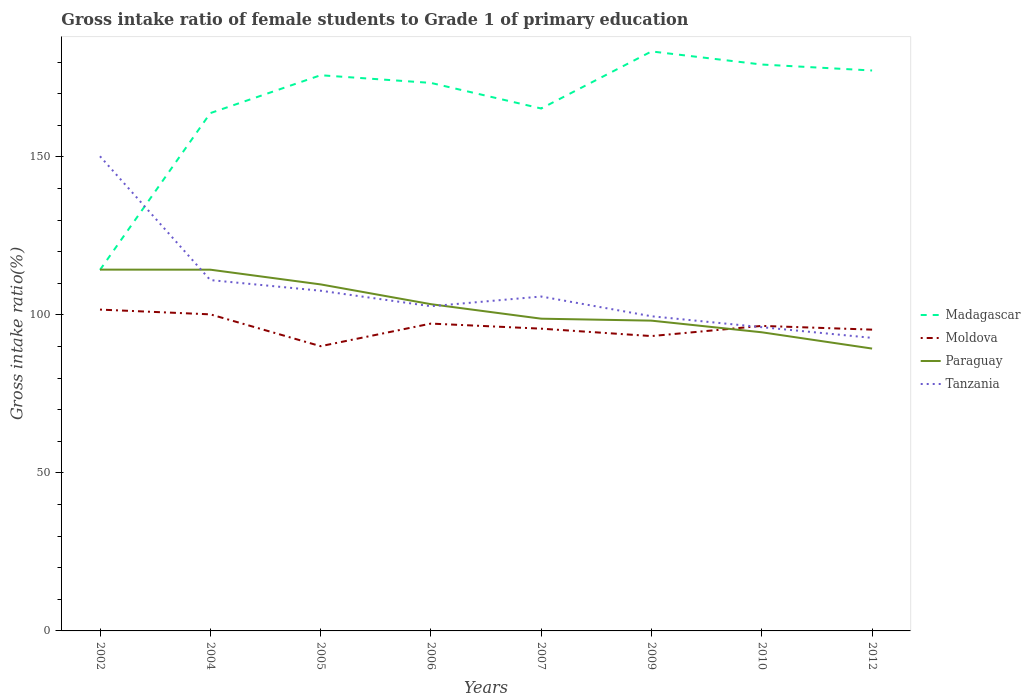How many different coloured lines are there?
Provide a succinct answer. 4. Does the line corresponding to Paraguay intersect with the line corresponding to Tanzania?
Ensure brevity in your answer.  Yes. Across all years, what is the maximum gross intake ratio in Paraguay?
Your response must be concise. 89.35. What is the total gross intake ratio in Paraguay in the graph?
Provide a short and direct response. 4.66. What is the difference between the highest and the second highest gross intake ratio in Tanzania?
Your answer should be very brief. 57.47. Is the gross intake ratio in Moldova strictly greater than the gross intake ratio in Tanzania over the years?
Your answer should be compact. No. How many lines are there?
Make the answer very short. 4. How many years are there in the graph?
Provide a short and direct response. 8. What is the difference between two consecutive major ticks on the Y-axis?
Your answer should be very brief. 50. Are the values on the major ticks of Y-axis written in scientific E-notation?
Offer a very short reply. No. Does the graph contain grids?
Give a very brief answer. No. Where does the legend appear in the graph?
Offer a terse response. Center right. What is the title of the graph?
Give a very brief answer. Gross intake ratio of female students to Grade 1 of primary education. What is the label or title of the Y-axis?
Make the answer very short. Gross intake ratio(%). What is the Gross intake ratio(%) of Madagascar in 2002?
Offer a terse response. 114.24. What is the Gross intake ratio(%) in Moldova in 2002?
Provide a short and direct response. 101.68. What is the Gross intake ratio(%) of Paraguay in 2002?
Your answer should be very brief. 114.33. What is the Gross intake ratio(%) in Tanzania in 2002?
Make the answer very short. 150.2. What is the Gross intake ratio(%) in Madagascar in 2004?
Provide a short and direct response. 163.85. What is the Gross intake ratio(%) in Moldova in 2004?
Make the answer very short. 100.18. What is the Gross intake ratio(%) of Paraguay in 2004?
Make the answer very short. 114.31. What is the Gross intake ratio(%) of Tanzania in 2004?
Your response must be concise. 111.02. What is the Gross intake ratio(%) of Madagascar in 2005?
Keep it short and to the point. 175.84. What is the Gross intake ratio(%) in Moldova in 2005?
Your response must be concise. 90.1. What is the Gross intake ratio(%) of Paraguay in 2005?
Keep it short and to the point. 109.65. What is the Gross intake ratio(%) in Tanzania in 2005?
Your response must be concise. 107.65. What is the Gross intake ratio(%) of Madagascar in 2006?
Provide a short and direct response. 173.41. What is the Gross intake ratio(%) in Moldova in 2006?
Your answer should be compact. 97.25. What is the Gross intake ratio(%) in Paraguay in 2006?
Provide a short and direct response. 103.4. What is the Gross intake ratio(%) in Tanzania in 2006?
Ensure brevity in your answer.  102.75. What is the Gross intake ratio(%) in Madagascar in 2007?
Offer a terse response. 165.32. What is the Gross intake ratio(%) in Moldova in 2007?
Ensure brevity in your answer.  95.64. What is the Gross intake ratio(%) in Paraguay in 2007?
Keep it short and to the point. 98.8. What is the Gross intake ratio(%) in Tanzania in 2007?
Ensure brevity in your answer.  105.82. What is the Gross intake ratio(%) in Madagascar in 2009?
Keep it short and to the point. 183.37. What is the Gross intake ratio(%) in Moldova in 2009?
Provide a succinct answer. 93.3. What is the Gross intake ratio(%) of Paraguay in 2009?
Provide a succinct answer. 98.18. What is the Gross intake ratio(%) of Tanzania in 2009?
Offer a very short reply. 99.57. What is the Gross intake ratio(%) of Madagascar in 2010?
Keep it short and to the point. 179.23. What is the Gross intake ratio(%) in Moldova in 2010?
Provide a short and direct response. 96.52. What is the Gross intake ratio(%) in Paraguay in 2010?
Give a very brief answer. 94.5. What is the Gross intake ratio(%) in Tanzania in 2010?
Make the answer very short. 96.12. What is the Gross intake ratio(%) in Madagascar in 2012?
Offer a very short reply. 177.34. What is the Gross intake ratio(%) of Moldova in 2012?
Provide a short and direct response. 95.34. What is the Gross intake ratio(%) of Paraguay in 2012?
Ensure brevity in your answer.  89.35. What is the Gross intake ratio(%) of Tanzania in 2012?
Provide a succinct answer. 92.73. Across all years, what is the maximum Gross intake ratio(%) in Madagascar?
Ensure brevity in your answer.  183.37. Across all years, what is the maximum Gross intake ratio(%) of Moldova?
Offer a very short reply. 101.68. Across all years, what is the maximum Gross intake ratio(%) in Paraguay?
Offer a terse response. 114.33. Across all years, what is the maximum Gross intake ratio(%) in Tanzania?
Offer a very short reply. 150.2. Across all years, what is the minimum Gross intake ratio(%) of Madagascar?
Ensure brevity in your answer.  114.24. Across all years, what is the minimum Gross intake ratio(%) of Moldova?
Offer a very short reply. 90.1. Across all years, what is the minimum Gross intake ratio(%) of Paraguay?
Give a very brief answer. 89.35. Across all years, what is the minimum Gross intake ratio(%) in Tanzania?
Make the answer very short. 92.73. What is the total Gross intake ratio(%) of Madagascar in the graph?
Provide a short and direct response. 1332.61. What is the total Gross intake ratio(%) in Moldova in the graph?
Ensure brevity in your answer.  770.02. What is the total Gross intake ratio(%) of Paraguay in the graph?
Offer a very short reply. 822.53. What is the total Gross intake ratio(%) of Tanzania in the graph?
Give a very brief answer. 865.86. What is the difference between the Gross intake ratio(%) in Madagascar in 2002 and that in 2004?
Keep it short and to the point. -49.61. What is the difference between the Gross intake ratio(%) of Moldova in 2002 and that in 2004?
Your answer should be very brief. 1.5. What is the difference between the Gross intake ratio(%) in Paraguay in 2002 and that in 2004?
Ensure brevity in your answer.  0.02. What is the difference between the Gross intake ratio(%) of Tanzania in 2002 and that in 2004?
Offer a terse response. 39.18. What is the difference between the Gross intake ratio(%) of Madagascar in 2002 and that in 2005?
Offer a terse response. -61.6. What is the difference between the Gross intake ratio(%) in Moldova in 2002 and that in 2005?
Your answer should be compact. 11.58. What is the difference between the Gross intake ratio(%) in Paraguay in 2002 and that in 2005?
Provide a short and direct response. 4.67. What is the difference between the Gross intake ratio(%) in Tanzania in 2002 and that in 2005?
Keep it short and to the point. 42.55. What is the difference between the Gross intake ratio(%) in Madagascar in 2002 and that in 2006?
Ensure brevity in your answer.  -59.17. What is the difference between the Gross intake ratio(%) in Moldova in 2002 and that in 2006?
Provide a short and direct response. 4.43. What is the difference between the Gross intake ratio(%) in Paraguay in 2002 and that in 2006?
Provide a succinct answer. 10.93. What is the difference between the Gross intake ratio(%) in Tanzania in 2002 and that in 2006?
Your response must be concise. 47.45. What is the difference between the Gross intake ratio(%) in Madagascar in 2002 and that in 2007?
Ensure brevity in your answer.  -51.07. What is the difference between the Gross intake ratio(%) of Moldova in 2002 and that in 2007?
Provide a short and direct response. 6.04. What is the difference between the Gross intake ratio(%) of Paraguay in 2002 and that in 2007?
Provide a succinct answer. 15.52. What is the difference between the Gross intake ratio(%) in Tanzania in 2002 and that in 2007?
Provide a short and direct response. 44.38. What is the difference between the Gross intake ratio(%) in Madagascar in 2002 and that in 2009?
Provide a succinct answer. -69.13. What is the difference between the Gross intake ratio(%) of Moldova in 2002 and that in 2009?
Your answer should be compact. 8.38. What is the difference between the Gross intake ratio(%) in Paraguay in 2002 and that in 2009?
Ensure brevity in your answer.  16.14. What is the difference between the Gross intake ratio(%) of Tanzania in 2002 and that in 2009?
Ensure brevity in your answer.  50.63. What is the difference between the Gross intake ratio(%) in Madagascar in 2002 and that in 2010?
Keep it short and to the point. -64.99. What is the difference between the Gross intake ratio(%) in Moldova in 2002 and that in 2010?
Provide a succinct answer. 5.16. What is the difference between the Gross intake ratio(%) in Paraguay in 2002 and that in 2010?
Your answer should be compact. 19.83. What is the difference between the Gross intake ratio(%) in Tanzania in 2002 and that in 2010?
Keep it short and to the point. 54.09. What is the difference between the Gross intake ratio(%) in Madagascar in 2002 and that in 2012?
Your answer should be very brief. -63.1. What is the difference between the Gross intake ratio(%) of Moldova in 2002 and that in 2012?
Offer a very short reply. 6.34. What is the difference between the Gross intake ratio(%) of Paraguay in 2002 and that in 2012?
Ensure brevity in your answer.  24.98. What is the difference between the Gross intake ratio(%) of Tanzania in 2002 and that in 2012?
Provide a succinct answer. 57.47. What is the difference between the Gross intake ratio(%) in Madagascar in 2004 and that in 2005?
Offer a very short reply. -11.99. What is the difference between the Gross intake ratio(%) in Moldova in 2004 and that in 2005?
Offer a terse response. 10.08. What is the difference between the Gross intake ratio(%) of Paraguay in 2004 and that in 2005?
Your answer should be compact. 4.66. What is the difference between the Gross intake ratio(%) of Tanzania in 2004 and that in 2005?
Keep it short and to the point. 3.37. What is the difference between the Gross intake ratio(%) in Madagascar in 2004 and that in 2006?
Your response must be concise. -9.56. What is the difference between the Gross intake ratio(%) of Moldova in 2004 and that in 2006?
Your answer should be very brief. 2.92. What is the difference between the Gross intake ratio(%) of Paraguay in 2004 and that in 2006?
Your response must be concise. 10.91. What is the difference between the Gross intake ratio(%) of Tanzania in 2004 and that in 2006?
Offer a terse response. 8.27. What is the difference between the Gross intake ratio(%) of Madagascar in 2004 and that in 2007?
Your answer should be compact. -1.46. What is the difference between the Gross intake ratio(%) in Moldova in 2004 and that in 2007?
Give a very brief answer. 4.53. What is the difference between the Gross intake ratio(%) of Paraguay in 2004 and that in 2007?
Give a very brief answer. 15.51. What is the difference between the Gross intake ratio(%) in Tanzania in 2004 and that in 2007?
Your answer should be compact. 5.2. What is the difference between the Gross intake ratio(%) in Madagascar in 2004 and that in 2009?
Make the answer very short. -19.52. What is the difference between the Gross intake ratio(%) of Moldova in 2004 and that in 2009?
Provide a succinct answer. 6.87. What is the difference between the Gross intake ratio(%) in Paraguay in 2004 and that in 2009?
Keep it short and to the point. 16.13. What is the difference between the Gross intake ratio(%) in Tanzania in 2004 and that in 2009?
Offer a very short reply. 11.45. What is the difference between the Gross intake ratio(%) of Madagascar in 2004 and that in 2010?
Your answer should be very brief. -15.38. What is the difference between the Gross intake ratio(%) in Moldova in 2004 and that in 2010?
Your response must be concise. 3.65. What is the difference between the Gross intake ratio(%) in Paraguay in 2004 and that in 2010?
Keep it short and to the point. 19.81. What is the difference between the Gross intake ratio(%) of Tanzania in 2004 and that in 2010?
Your answer should be very brief. 14.9. What is the difference between the Gross intake ratio(%) in Madagascar in 2004 and that in 2012?
Offer a terse response. -13.49. What is the difference between the Gross intake ratio(%) of Moldova in 2004 and that in 2012?
Provide a short and direct response. 4.84. What is the difference between the Gross intake ratio(%) of Paraguay in 2004 and that in 2012?
Provide a succinct answer. 24.96. What is the difference between the Gross intake ratio(%) of Tanzania in 2004 and that in 2012?
Your response must be concise. 18.29. What is the difference between the Gross intake ratio(%) in Madagascar in 2005 and that in 2006?
Make the answer very short. 2.43. What is the difference between the Gross intake ratio(%) in Moldova in 2005 and that in 2006?
Your answer should be very brief. -7.15. What is the difference between the Gross intake ratio(%) in Paraguay in 2005 and that in 2006?
Ensure brevity in your answer.  6.26. What is the difference between the Gross intake ratio(%) in Tanzania in 2005 and that in 2006?
Provide a succinct answer. 4.91. What is the difference between the Gross intake ratio(%) of Madagascar in 2005 and that in 2007?
Provide a succinct answer. 10.53. What is the difference between the Gross intake ratio(%) of Moldova in 2005 and that in 2007?
Your answer should be compact. -5.54. What is the difference between the Gross intake ratio(%) of Paraguay in 2005 and that in 2007?
Provide a succinct answer. 10.85. What is the difference between the Gross intake ratio(%) of Tanzania in 2005 and that in 2007?
Provide a short and direct response. 1.83. What is the difference between the Gross intake ratio(%) in Madagascar in 2005 and that in 2009?
Ensure brevity in your answer.  -7.53. What is the difference between the Gross intake ratio(%) of Moldova in 2005 and that in 2009?
Provide a short and direct response. -3.2. What is the difference between the Gross intake ratio(%) of Paraguay in 2005 and that in 2009?
Keep it short and to the point. 11.47. What is the difference between the Gross intake ratio(%) in Tanzania in 2005 and that in 2009?
Your answer should be compact. 8.08. What is the difference between the Gross intake ratio(%) in Madagascar in 2005 and that in 2010?
Your answer should be compact. -3.39. What is the difference between the Gross intake ratio(%) of Moldova in 2005 and that in 2010?
Your answer should be very brief. -6.42. What is the difference between the Gross intake ratio(%) of Paraguay in 2005 and that in 2010?
Provide a succinct answer. 15.15. What is the difference between the Gross intake ratio(%) of Tanzania in 2005 and that in 2010?
Offer a very short reply. 11.54. What is the difference between the Gross intake ratio(%) of Madagascar in 2005 and that in 2012?
Your response must be concise. -1.5. What is the difference between the Gross intake ratio(%) of Moldova in 2005 and that in 2012?
Keep it short and to the point. -5.24. What is the difference between the Gross intake ratio(%) of Paraguay in 2005 and that in 2012?
Your answer should be very brief. 20.31. What is the difference between the Gross intake ratio(%) of Tanzania in 2005 and that in 2012?
Your answer should be compact. 14.92. What is the difference between the Gross intake ratio(%) of Madagascar in 2006 and that in 2007?
Ensure brevity in your answer.  8.1. What is the difference between the Gross intake ratio(%) in Moldova in 2006 and that in 2007?
Ensure brevity in your answer.  1.61. What is the difference between the Gross intake ratio(%) of Paraguay in 2006 and that in 2007?
Ensure brevity in your answer.  4.59. What is the difference between the Gross intake ratio(%) of Tanzania in 2006 and that in 2007?
Ensure brevity in your answer.  -3.07. What is the difference between the Gross intake ratio(%) of Madagascar in 2006 and that in 2009?
Offer a very short reply. -9.96. What is the difference between the Gross intake ratio(%) of Moldova in 2006 and that in 2009?
Offer a very short reply. 3.95. What is the difference between the Gross intake ratio(%) of Paraguay in 2006 and that in 2009?
Keep it short and to the point. 5.21. What is the difference between the Gross intake ratio(%) of Tanzania in 2006 and that in 2009?
Your response must be concise. 3.18. What is the difference between the Gross intake ratio(%) of Madagascar in 2006 and that in 2010?
Your response must be concise. -5.82. What is the difference between the Gross intake ratio(%) of Moldova in 2006 and that in 2010?
Offer a very short reply. 0.73. What is the difference between the Gross intake ratio(%) in Paraguay in 2006 and that in 2010?
Provide a succinct answer. 8.89. What is the difference between the Gross intake ratio(%) in Tanzania in 2006 and that in 2010?
Your answer should be compact. 6.63. What is the difference between the Gross intake ratio(%) in Madagascar in 2006 and that in 2012?
Keep it short and to the point. -3.93. What is the difference between the Gross intake ratio(%) of Moldova in 2006 and that in 2012?
Provide a short and direct response. 1.92. What is the difference between the Gross intake ratio(%) in Paraguay in 2006 and that in 2012?
Offer a terse response. 14.05. What is the difference between the Gross intake ratio(%) of Tanzania in 2006 and that in 2012?
Your answer should be very brief. 10.02. What is the difference between the Gross intake ratio(%) in Madagascar in 2007 and that in 2009?
Ensure brevity in your answer.  -18.06. What is the difference between the Gross intake ratio(%) of Moldova in 2007 and that in 2009?
Your answer should be compact. 2.34. What is the difference between the Gross intake ratio(%) of Paraguay in 2007 and that in 2009?
Make the answer very short. 0.62. What is the difference between the Gross intake ratio(%) in Tanzania in 2007 and that in 2009?
Provide a succinct answer. 6.25. What is the difference between the Gross intake ratio(%) in Madagascar in 2007 and that in 2010?
Your response must be concise. -13.91. What is the difference between the Gross intake ratio(%) in Moldova in 2007 and that in 2010?
Your answer should be compact. -0.88. What is the difference between the Gross intake ratio(%) in Paraguay in 2007 and that in 2010?
Provide a succinct answer. 4.3. What is the difference between the Gross intake ratio(%) in Tanzania in 2007 and that in 2010?
Ensure brevity in your answer.  9.7. What is the difference between the Gross intake ratio(%) of Madagascar in 2007 and that in 2012?
Your answer should be very brief. -12.02. What is the difference between the Gross intake ratio(%) in Moldova in 2007 and that in 2012?
Make the answer very short. 0.31. What is the difference between the Gross intake ratio(%) of Paraguay in 2007 and that in 2012?
Provide a succinct answer. 9.46. What is the difference between the Gross intake ratio(%) in Tanzania in 2007 and that in 2012?
Your answer should be compact. 13.09. What is the difference between the Gross intake ratio(%) of Madagascar in 2009 and that in 2010?
Make the answer very short. 4.14. What is the difference between the Gross intake ratio(%) of Moldova in 2009 and that in 2010?
Give a very brief answer. -3.22. What is the difference between the Gross intake ratio(%) in Paraguay in 2009 and that in 2010?
Give a very brief answer. 3.68. What is the difference between the Gross intake ratio(%) in Tanzania in 2009 and that in 2010?
Provide a succinct answer. 3.45. What is the difference between the Gross intake ratio(%) in Madagascar in 2009 and that in 2012?
Your answer should be compact. 6.03. What is the difference between the Gross intake ratio(%) of Moldova in 2009 and that in 2012?
Your response must be concise. -2.03. What is the difference between the Gross intake ratio(%) in Paraguay in 2009 and that in 2012?
Keep it short and to the point. 8.84. What is the difference between the Gross intake ratio(%) of Tanzania in 2009 and that in 2012?
Give a very brief answer. 6.84. What is the difference between the Gross intake ratio(%) in Madagascar in 2010 and that in 2012?
Your answer should be very brief. 1.89. What is the difference between the Gross intake ratio(%) of Moldova in 2010 and that in 2012?
Your response must be concise. 1.19. What is the difference between the Gross intake ratio(%) of Paraguay in 2010 and that in 2012?
Offer a very short reply. 5.15. What is the difference between the Gross intake ratio(%) in Tanzania in 2010 and that in 2012?
Your response must be concise. 3.38. What is the difference between the Gross intake ratio(%) in Madagascar in 2002 and the Gross intake ratio(%) in Moldova in 2004?
Ensure brevity in your answer.  14.07. What is the difference between the Gross intake ratio(%) in Madagascar in 2002 and the Gross intake ratio(%) in Paraguay in 2004?
Ensure brevity in your answer.  -0.07. What is the difference between the Gross intake ratio(%) of Madagascar in 2002 and the Gross intake ratio(%) of Tanzania in 2004?
Provide a short and direct response. 3.22. What is the difference between the Gross intake ratio(%) of Moldova in 2002 and the Gross intake ratio(%) of Paraguay in 2004?
Keep it short and to the point. -12.63. What is the difference between the Gross intake ratio(%) in Moldova in 2002 and the Gross intake ratio(%) in Tanzania in 2004?
Keep it short and to the point. -9.34. What is the difference between the Gross intake ratio(%) of Paraguay in 2002 and the Gross intake ratio(%) of Tanzania in 2004?
Give a very brief answer. 3.31. What is the difference between the Gross intake ratio(%) in Madagascar in 2002 and the Gross intake ratio(%) in Moldova in 2005?
Provide a short and direct response. 24.14. What is the difference between the Gross intake ratio(%) in Madagascar in 2002 and the Gross intake ratio(%) in Paraguay in 2005?
Provide a succinct answer. 4.59. What is the difference between the Gross intake ratio(%) of Madagascar in 2002 and the Gross intake ratio(%) of Tanzania in 2005?
Provide a short and direct response. 6.59. What is the difference between the Gross intake ratio(%) in Moldova in 2002 and the Gross intake ratio(%) in Paraguay in 2005?
Your answer should be very brief. -7.97. What is the difference between the Gross intake ratio(%) in Moldova in 2002 and the Gross intake ratio(%) in Tanzania in 2005?
Ensure brevity in your answer.  -5.97. What is the difference between the Gross intake ratio(%) of Paraguay in 2002 and the Gross intake ratio(%) of Tanzania in 2005?
Offer a terse response. 6.67. What is the difference between the Gross intake ratio(%) of Madagascar in 2002 and the Gross intake ratio(%) of Moldova in 2006?
Ensure brevity in your answer.  16.99. What is the difference between the Gross intake ratio(%) of Madagascar in 2002 and the Gross intake ratio(%) of Paraguay in 2006?
Your response must be concise. 10.85. What is the difference between the Gross intake ratio(%) in Madagascar in 2002 and the Gross intake ratio(%) in Tanzania in 2006?
Ensure brevity in your answer.  11.5. What is the difference between the Gross intake ratio(%) of Moldova in 2002 and the Gross intake ratio(%) of Paraguay in 2006?
Ensure brevity in your answer.  -1.72. What is the difference between the Gross intake ratio(%) of Moldova in 2002 and the Gross intake ratio(%) of Tanzania in 2006?
Make the answer very short. -1.07. What is the difference between the Gross intake ratio(%) of Paraguay in 2002 and the Gross intake ratio(%) of Tanzania in 2006?
Provide a short and direct response. 11.58. What is the difference between the Gross intake ratio(%) of Madagascar in 2002 and the Gross intake ratio(%) of Moldova in 2007?
Make the answer very short. 18.6. What is the difference between the Gross intake ratio(%) in Madagascar in 2002 and the Gross intake ratio(%) in Paraguay in 2007?
Provide a succinct answer. 15.44. What is the difference between the Gross intake ratio(%) of Madagascar in 2002 and the Gross intake ratio(%) of Tanzania in 2007?
Offer a terse response. 8.42. What is the difference between the Gross intake ratio(%) in Moldova in 2002 and the Gross intake ratio(%) in Paraguay in 2007?
Your answer should be compact. 2.88. What is the difference between the Gross intake ratio(%) in Moldova in 2002 and the Gross intake ratio(%) in Tanzania in 2007?
Provide a short and direct response. -4.14. What is the difference between the Gross intake ratio(%) in Paraguay in 2002 and the Gross intake ratio(%) in Tanzania in 2007?
Give a very brief answer. 8.51. What is the difference between the Gross intake ratio(%) of Madagascar in 2002 and the Gross intake ratio(%) of Moldova in 2009?
Offer a terse response. 20.94. What is the difference between the Gross intake ratio(%) in Madagascar in 2002 and the Gross intake ratio(%) in Paraguay in 2009?
Provide a short and direct response. 16.06. What is the difference between the Gross intake ratio(%) of Madagascar in 2002 and the Gross intake ratio(%) of Tanzania in 2009?
Ensure brevity in your answer.  14.67. What is the difference between the Gross intake ratio(%) of Moldova in 2002 and the Gross intake ratio(%) of Paraguay in 2009?
Make the answer very short. 3.5. What is the difference between the Gross intake ratio(%) in Moldova in 2002 and the Gross intake ratio(%) in Tanzania in 2009?
Keep it short and to the point. 2.11. What is the difference between the Gross intake ratio(%) of Paraguay in 2002 and the Gross intake ratio(%) of Tanzania in 2009?
Your response must be concise. 14.76. What is the difference between the Gross intake ratio(%) in Madagascar in 2002 and the Gross intake ratio(%) in Moldova in 2010?
Offer a terse response. 17.72. What is the difference between the Gross intake ratio(%) of Madagascar in 2002 and the Gross intake ratio(%) of Paraguay in 2010?
Your answer should be very brief. 19.74. What is the difference between the Gross intake ratio(%) of Madagascar in 2002 and the Gross intake ratio(%) of Tanzania in 2010?
Your answer should be compact. 18.13. What is the difference between the Gross intake ratio(%) in Moldova in 2002 and the Gross intake ratio(%) in Paraguay in 2010?
Your answer should be very brief. 7.18. What is the difference between the Gross intake ratio(%) in Moldova in 2002 and the Gross intake ratio(%) in Tanzania in 2010?
Your answer should be compact. 5.56. What is the difference between the Gross intake ratio(%) in Paraguay in 2002 and the Gross intake ratio(%) in Tanzania in 2010?
Your response must be concise. 18.21. What is the difference between the Gross intake ratio(%) in Madagascar in 2002 and the Gross intake ratio(%) in Moldova in 2012?
Your response must be concise. 18.91. What is the difference between the Gross intake ratio(%) of Madagascar in 2002 and the Gross intake ratio(%) of Paraguay in 2012?
Give a very brief answer. 24.9. What is the difference between the Gross intake ratio(%) in Madagascar in 2002 and the Gross intake ratio(%) in Tanzania in 2012?
Offer a very short reply. 21.51. What is the difference between the Gross intake ratio(%) in Moldova in 2002 and the Gross intake ratio(%) in Paraguay in 2012?
Ensure brevity in your answer.  12.33. What is the difference between the Gross intake ratio(%) in Moldova in 2002 and the Gross intake ratio(%) in Tanzania in 2012?
Offer a terse response. 8.95. What is the difference between the Gross intake ratio(%) in Paraguay in 2002 and the Gross intake ratio(%) in Tanzania in 2012?
Your answer should be very brief. 21.6. What is the difference between the Gross intake ratio(%) of Madagascar in 2004 and the Gross intake ratio(%) of Moldova in 2005?
Your answer should be very brief. 73.75. What is the difference between the Gross intake ratio(%) of Madagascar in 2004 and the Gross intake ratio(%) of Paraguay in 2005?
Keep it short and to the point. 54.2. What is the difference between the Gross intake ratio(%) of Madagascar in 2004 and the Gross intake ratio(%) of Tanzania in 2005?
Provide a short and direct response. 56.2. What is the difference between the Gross intake ratio(%) of Moldova in 2004 and the Gross intake ratio(%) of Paraguay in 2005?
Ensure brevity in your answer.  -9.48. What is the difference between the Gross intake ratio(%) in Moldova in 2004 and the Gross intake ratio(%) in Tanzania in 2005?
Provide a short and direct response. -7.48. What is the difference between the Gross intake ratio(%) in Paraguay in 2004 and the Gross intake ratio(%) in Tanzania in 2005?
Make the answer very short. 6.66. What is the difference between the Gross intake ratio(%) in Madagascar in 2004 and the Gross intake ratio(%) in Moldova in 2006?
Provide a succinct answer. 66.6. What is the difference between the Gross intake ratio(%) in Madagascar in 2004 and the Gross intake ratio(%) in Paraguay in 2006?
Your response must be concise. 60.46. What is the difference between the Gross intake ratio(%) of Madagascar in 2004 and the Gross intake ratio(%) of Tanzania in 2006?
Your answer should be very brief. 61.11. What is the difference between the Gross intake ratio(%) of Moldova in 2004 and the Gross intake ratio(%) of Paraguay in 2006?
Provide a short and direct response. -3.22. What is the difference between the Gross intake ratio(%) in Moldova in 2004 and the Gross intake ratio(%) in Tanzania in 2006?
Offer a terse response. -2.57. What is the difference between the Gross intake ratio(%) of Paraguay in 2004 and the Gross intake ratio(%) of Tanzania in 2006?
Keep it short and to the point. 11.56. What is the difference between the Gross intake ratio(%) of Madagascar in 2004 and the Gross intake ratio(%) of Moldova in 2007?
Give a very brief answer. 68.21. What is the difference between the Gross intake ratio(%) of Madagascar in 2004 and the Gross intake ratio(%) of Paraguay in 2007?
Provide a short and direct response. 65.05. What is the difference between the Gross intake ratio(%) of Madagascar in 2004 and the Gross intake ratio(%) of Tanzania in 2007?
Ensure brevity in your answer.  58.03. What is the difference between the Gross intake ratio(%) in Moldova in 2004 and the Gross intake ratio(%) in Paraguay in 2007?
Provide a short and direct response. 1.37. What is the difference between the Gross intake ratio(%) in Moldova in 2004 and the Gross intake ratio(%) in Tanzania in 2007?
Your response must be concise. -5.64. What is the difference between the Gross intake ratio(%) of Paraguay in 2004 and the Gross intake ratio(%) of Tanzania in 2007?
Provide a short and direct response. 8.49. What is the difference between the Gross intake ratio(%) in Madagascar in 2004 and the Gross intake ratio(%) in Moldova in 2009?
Ensure brevity in your answer.  70.55. What is the difference between the Gross intake ratio(%) of Madagascar in 2004 and the Gross intake ratio(%) of Paraguay in 2009?
Your answer should be very brief. 65.67. What is the difference between the Gross intake ratio(%) of Madagascar in 2004 and the Gross intake ratio(%) of Tanzania in 2009?
Keep it short and to the point. 64.28. What is the difference between the Gross intake ratio(%) in Moldova in 2004 and the Gross intake ratio(%) in Paraguay in 2009?
Give a very brief answer. 1.99. What is the difference between the Gross intake ratio(%) in Moldova in 2004 and the Gross intake ratio(%) in Tanzania in 2009?
Make the answer very short. 0.61. What is the difference between the Gross intake ratio(%) in Paraguay in 2004 and the Gross intake ratio(%) in Tanzania in 2009?
Your answer should be very brief. 14.74. What is the difference between the Gross intake ratio(%) of Madagascar in 2004 and the Gross intake ratio(%) of Moldova in 2010?
Provide a short and direct response. 67.33. What is the difference between the Gross intake ratio(%) in Madagascar in 2004 and the Gross intake ratio(%) in Paraguay in 2010?
Keep it short and to the point. 69.35. What is the difference between the Gross intake ratio(%) in Madagascar in 2004 and the Gross intake ratio(%) in Tanzania in 2010?
Offer a very short reply. 67.74. What is the difference between the Gross intake ratio(%) of Moldova in 2004 and the Gross intake ratio(%) of Paraguay in 2010?
Keep it short and to the point. 5.67. What is the difference between the Gross intake ratio(%) in Moldova in 2004 and the Gross intake ratio(%) in Tanzania in 2010?
Give a very brief answer. 4.06. What is the difference between the Gross intake ratio(%) in Paraguay in 2004 and the Gross intake ratio(%) in Tanzania in 2010?
Give a very brief answer. 18.19. What is the difference between the Gross intake ratio(%) of Madagascar in 2004 and the Gross intake ratio(%) of Moldova in 2012?
Offer a terse response. 68.52. What is the difference between the Gross intake ratio(%) of Madagascar in 2004 and the Gross intake ratio(%) of Paraguay in 2012?
Keep it short and to the point. 74.5. What is the difference between the Gross intake ratio(%) of Madagascar in 2004 and the Gross intake ratio(%) of Tanzania in 2012?
Provide a short and direct response. 71.12. What is the difference between the Gross intake ratio(%) in Moldova in 2004 and the Gross intake ratio(%) in Paraguay in 2012?
Give a very brief answer. 10.83. What is the difference between the Gross intake ratio(%) in Moldova in 2004 and the Gross intake ratio(%) in Tanzania in 2012?
Your answer should be compact. 7.44. What is the difference between the Gross intake ratio(%) of Paraguay in 2004 and the Gross intake ratio(%) of Tanzania in 2012?
Your answer should be very brief. 21.58. What is the difference between the Gross intake ratio(%) in Madagascar in 2005 and the Gross intake ratio(%) in Moldova in 2006?
Keep it short and to the point. 78.59. What is the difference between the Gross intake ratio(%) in Madagascar in 2005 and the Gross intake ratio(%) in Paraguay in 2006?
Ensure brevity in your answer.  72.45. What is the difference between the Gross intake ratio(%) of Madagascar in 2005 and the Gross intake ratio(%) of Tanzania in 2006?
Provide a short and direct response. 73.1. What is the difference between the Gross intake ratio(%) of Moldova in 2005 and the Gross intake ratio(%) of Paraguay in 2006?
Your answer should be very brief. -13.3. What is the difference between the Gross intake ratio(%) in Moldova in 2005 and the Gross intake ratio(%) in Tanzania in 2006?
Ensure brevity in your answer.  -12.65. What is the difference between the Gross intake ratio(%) of Paraguay in 2005 and the Gross intake ratio(%) of Tanzania in 2006?
Your response must be concise. 6.91. What is the difference between the Gross intake ratio(%) of Madagascar in 2005 and the Gross intake ratio(%) of Moldova in 2007?
Offer a very short reply. 80.2. What is the difference between the Gross intake ratio(%) of Madagascar in 2005 and the Gross intake ratio(%) of Paraguay in 2007?
Ensure brevity in your answer.  77.04. What is the difference between the Gross intake ratio(%) in Madagascar in 2005 and the Gross intake ratio(%) in Tanzania in 2007?
Your response must be concise. 70.02. What is the difference between the Gross intake ratio(%) of Moldova in 2005 and the Gross intake ratio(%) of Paraguay in 2007?
Your response must be concise. -8.7. What is the difference between the Gross intake ratio(%) in Moldova in 2005 and the Gross intake ratio(%) in Tanzania in 2007?
Provide a succinct answer. -15.72. What is the difference between the Gross intake ratio(%) in Paraguay in 2005 and the Gross intake ratio(%) in Tanzania in 2007?
Your answer should be very brief. 3.84. What is the difference between the Gross intake ratio(%) in Madagascar in 2005 and the Gross intake ratio(%) in Moldova in 2009?
Your answer should be very brief. 82.54. What is the difference between the Gross intake ratio(%) of Madagascar in 2005 and the Gross intake ratio(%) of Paraguay in 2009?
Provide a short and direct response. 77.66. What is the difference between the Gross intake ratio(%) of Madagascar in 2005 and the Gross intake ratio(%) of Tanzania in 2009?
Ensure brevity in your answer.  76.27. What is the difference between the Gross intake ratio(%) of Moldova in 2005 and the Gross intake ratio(%) of Paraguay in 2009?
Provide a short and direct response. -8.08. What is the difference between the Gross intake ratio(%) in Moldova in 2005 and the Gross intake ratio(%) in Tanzania in 2009?
Give a very brief answer. -9.47. What is the difference between the Gross intake ratio(%) of Paraguay in 2005 and the Gross intake ratio(%) of Tanzania in 2009?
Keep it short and to the point. 10.09. What is the difference between the Gross intake ratio(%) of Madagascar in 2005 and the Gross intake ratio(%) of Moldova in 2010?
Offer a terse response. 79.32. What is the difference between the Gross intake ratio(%) in Madagascar in 2005 and the Gross intake ratio(%) in Paraguay in 2010?
Your response must be concise. 81.34. What is the difference between the Gross intake ratio(%) in Madagascar in 2005 and the Gross intake ratio(%) in Tanzania in 2010?
Your answer should be very brief. 79.73. What is the difference between the Gross intake ratio(%) in Moldova in 2005 and the Gross intake ratio(%) in Paraguay in 2010?
Give a very brief answer. -4.4. What is the difference between the Gross intake ratio(%) in Moldova in 2005 and the Gross intake ratio(%) in Tanzania in 2010?
Provide a short and direct response. -6.02. What is the difference between the Gross intake ratio(%) of Paraguay in 2005 and the Gross intake ratio(%) of Tanzania in 2010?
Your response must be concise. 13.54. What is the difference between the Gross intake ratio(%) in Madagascar in 2005 and the Gross intake ratio(%) in Moldova in 2012?
Make the answer very short. 80.51. What is the difference between the Gross intake ratio(%) in Madagascar in 2005 and the Gross intake ratio(%) in Paraguay in 2012?
Ensure brevity in your answer.  86.5. What is the difference between the Gross intake ratio(%) in Madagascar in 2005 and the Gross intake ratio(%) in Tanzania in 2012?
Your answer should be very brief. 83.11. What is the difference between the Gross intake ratio(%) in Moldova in 2005 and the Gross intake ratio(%) in Paraguay in 2012?
Keep it short and to the point. 0.75. What is the difference between the Gross intake ratio(%) of Moldova in 2005 and the Gross intake ratio(%) of Tanzania in 2012?
Ensure brevity in your answer.  -2.63. What is the difference between the Gross intake ratio(%) of Paraguay in 2005 and the Gross intake ratio(%) of Tanzania in 2012?
Give a very brief answer. 16.92. What is the difference between the Gross intake ratio(%) in Madagascar in 2006 and the Gross intake ratio(%) in Moldova in 2007?
Provide a succinct answer. 77.77. What is the difference between the Gross intake ratio(%) of Madagascar in 2006 and the Gross intake ratio(%) of Paraguay in 2007?
Give a very brief answer. 74.61. What is the difference between the Gross intake ratio(%) of Madagascar in 2006 and the Gross intake ratio(%) of Tanzania in 2007?
Provide a short and direct response. 67.6. What is the difference between the Gross intake ratio(%) in Moldova in 2006 and the Gross intake ratio(%) in Paraguay in 2007?
Ensure brevity in your answer.  -1.55. What is the difference between the Gross intake ratio(%) in Moldova in 2006 and the Gross intake ratio(%) in Tanzania in 2007?
Offer a very short reply. -8.57. What is the difference between the Gross intake ratio(%) of Paraguay in 2006 and the Gross intake ratio(%) of Tanzania in 2007?
Provide a succinct answer. -2.42. What is the difference between the Gross intake ratio(%) in Madagascar in 2006 and the Gross intake ratio(%) in Moldova in 2009?
Keep it short and to the point. 80.11. What is the difference between the Gross intake ratio(%) of Madagascar in 2006 and the Gross intake ratio(%) of Paraguay in 2009?
Your answer should be compact. 75.23. What is the difference between the Gross intake ratio(%) in Madagascar in 2006 and the Gross intake ratio(%) in Tanzania in 2009?
Offer a terse response. 73.85. What is the difference between the Gross intake ratio(%) of Moldova in 2006 and the Gross intake ratio(%) of Paraguay in 2009?
Your answer should be compact. -0.93. What is the difference between the Gross intake ratio(%) in Moldova in 2006 and the Gross intake ratio(%) in Tanzania in 2009?
Your response must be concise. -2.32. What is the difference between the Gross intake ratio(%) in Paraguay in 2006 and the Gross intake ratio(%) in Tanzania in 2009?
Your response must be concise. 3.83. What is the difference between the Gross intake ratio(%) in Madagascar in 2006 and the Gross intake ratio(%) in Moldova in 2010?
Offer a very short reply. 76.89. What is the difference between the Gross intake ratio(%) in Madagascar in 2006 and the Gross intake ratio(%) in Paraguay in 2010?
Make the answer very short. 78.91. What is the difference between the Gross intake ratio(%) in Madagascar in 2006 and the Gross intake ratio(%) in Tanzania in 2010?
Provide a succinct answer. 77.3. What is the difference between the Gross intake ratio(%) of Moldova in 2006 and the Gross intake ratio(%) of Paraguay in 2010?
Ensure brevity in your answer.  2.75. What is the difference between the Gross intake ratio(%) of Moldova in 2006 and the Gross intake ratio(%) of Tanzania in 2010?
Offer a terse response. 1.14. What is the difference between the Gross intake ratio(%) in Paraguay in 2006 and the Gross intake ratio(%) in Tanzania in 2010?
Give a very brief answer. 7.28. What is the difference between the Gross intake ratio(%) of Madagascar in 2006 and the Gross intake ratio(%) of Moldova in 2012?
Provide a succinct answer. 78.08. What is the difference between the Gross intake ratio(%) in Madagascar in 2006 and the Gross intake ratio(%) in Paraguay in 2012?
Your response must be concise. 84.07. What is the difference between the Gross intake ratio(%) of Madagascar in 2006 and the Gross intake ratio(%) of Tanzania in 2012?
Keep it short and to the point. 80.68. What is the difference between the Gross intake ratio(%) in Moldova in 2006 and the Gross intake ratio(%) in Paraguay in 2012?
Offer a terse response. 7.91. What is the difference between the Gross intake ratio(%) of Moldova in 2006 and the Gross intake ratio(%) of Tanzania in 2012?
Keep it short and to the point. 4.52. What is the difference between the Gross intake ratio(%) in Paraguay in 2006 and the Gross intake ratio(%) in Tanzania in 2012?
Your answer should be compact. 10.66. What is the difference between the Gross intake ratio(%) of Madagascar in 2007 and the Gross intake ratio(%) of Moldova in 2009?
Offer a terse response. 72.01. What is the difference between the Gross intake ratio(%) in Madagascar in 2007 and the Gross intake ratio(%) in Paraguay in 2009?
Your answer should be compact. 67.13. What is the difference between the Gross intake ratio(%) in Madagascar in 2007 and the Gross intake ratio(%) in Tanzania in 2009?
Your response must be concise. 65.75. What is the difference between the Gross intake ratio(%) in Moldova in 2007 and the Gross intake ratio(%) in Paraguay in 2009?
Provide a succinct answer. -2.54. What is the difference between the Gross intake ratio(%) of Moldova in 2007 and the Gross intake ratio(%) of Tanzania in 2009?
Your answer should be very brief. -3.93. What is the difference between the Gross intake ratio(%) of Paraguay in 2007 and the Gross intake ratio(%) of Tanzania in 2009?
Ensure brevity in your answer.  -0.76. What is the difference between the Gross intake ratio(%) of Madagascar in 2007 and the Gross intake ratio(%) of Moldova in 2010?
Ensure brevity in your answer.  68.79. What is the difference between the Gross intake ratio(%) in Madagascar in 2007 and the Gross intake ratio(%) in Paraguay in 2010?
Make the answer very short. 70.81. What is the difference between the Gross intake ratio(%) of Madagascar in 2007 and the Gross intake ratio(%) of Tanzania in 2010?
Your answer should be very brief. 69.2. What is the difference between the Gross intake ratio(%) in Moldova in 2007 and the Gross intake ratio(%) in Paraguay in 2010?
Your response must be concise. 1.14. What is the difference between the Gross intake ratio(%) in Moldova in 2007 and the Gross intake ratio(%) in Tanzania in 2010?
Give a very brief answer. -0.47. What is the difference between the Gross intake ratio(%) in Paraguay in 2007 and the Gross intake ratio(%) in Tanzania in 2010?
Keep it short and to the point. 2.69. What is the difference between the Gross intake ratio(%) in Madagascar in 2007 and the Gross intake ratio(%) in Moldova in 2012?
Give a very brief answer. 69.98. What is the difference between the Gross intake ratio(%) of Madagascar in 2007 and the Gross intake ratio(%) of Paraguay in 2012?
Your answer should be very brief. 75.97. What is the difference between the Gross intake ratio(%) of Madagascar in 2007 and the Gross intake ratio(%) of Tanzania in 2012?
Give a very brief answer. 72.58. What is the difference between the Gross intake ratio(%) in Moldova in 2007 and the Gross intake ratio(%) in Paraguay in 2012?
Offer a very short reply. 6.3. What is the difference between the Gross intake ratio(%) in Moldova in 2007 and the Gross intake ratio(%) in Tanzania in 2012?
Make the answer very short. 2.91. What is the difference between the Gross intake ratio(%) of Paraguay in 2007 and the Gross intake ratio(%) of Tanzania in 2012?
Keep it short and to the point. 6.07. What is the difference between the Gross intake ratio(%) in Madagascar in 2009 and the Gross intake ratio(%) in Moldova in 2010?
Your answer should be very brief. 86.85. What is the difference between the Gross intake ratio(%) in Madagascar in 2009 and the Gross intake ratio(%) in Paraguay in 2010?
Your answer should be compact. 88.87. What is the difference between the Gross intake ratio(%) in Madagascar in 2009 and the Gross intake ratio(%) in Tanzania in 2010?
Offer a very short reply. 87.26. What is the difference between the Gross intake ratio(%) in Moldova in 2009 and the Gross intake ratio(%) in Paraguay in 2010?
Keep it short and to the point. -1.2. What is the difference between the Gross intake ratio(%) of Moldova in 2009 and the Gross intake ratio(%) of Tanzania in 2010?
Provide a short and direct response. -2.81. What is the difference between the Gross intake ratio(%) of Paraguay in 2009 and the Gross intake ratio(%) of Tanzania in 2010?
Your answer should be very brief. 2.07. What is the difference between the Gross intake ratio(%) in Madagascar in 2009 and the Gross intake ratio(%) in Moldova in 2012?
Provide a short and direct response. 88.04. What is the difference between the Gross intake ratio(%) of Madagascar in 2009 and the Gross intake ratio(%) of Paraguay in 2012?
Keep it short and to the point. 94.03. What is the difference between the Gross intake ratio(%) of Madagascar in 2009 and the Gross intake ratio(%) of Tanzania in 2012?
Offer a very short reply. 90.64. What is the difference between the Gross intake ratio(%) of Moldova in 2009 and the Gross intake ratio(%) of Paraguay in 2012?
Make the answer very short. 3.96. What is the difference between the Gross intake ratio(%) of Moldova in 2009 and the Gross intake ratio(%) of Tanzania in 2012?
Make the answer very short. 0.57. What is the difference between the Gross intake ratio(%) of Paraguay in 2009 and the Gross intake ratio(%) of Tanzania in 2012?
Offer a terse response. 5.45. What is the difference between the Gross intake ratio(%) of Madagascar in 2010 and the Gross intake ratio(%) of Moldova in 2012?
Your answer should be very brief. 83.89. What is the difference between the Gross intake ratio(%) in Madagascar in 2010 and the Gross intake ratio(%) in Paraguay in 2012?
Offer a terse response. 89.88. What is the difference between the Gross intake ratio(%) in Madagascar in 2010 and the Gross intake ratio(%) in Tanzania in 2012?
Make the answer very short. 86.5. What is the difference between the Gross intake ratio(%) of Moldova in 2010 and the Gross intake ratio(%) of Paraguay in 2012?
Your answer should be compact. 7.18. What is the difference between the Gross intake ratio(%) of Moldova in 2010 and the Gross intake ratio(%) of Tanzania in 2012?
Make the answer very short. 3.79. What is the difference between the Gross intake ratio(%) in Paraguay in 2010 and the Gross intake ratio(%) in Tanzania in 2012?
Offer a terse response. 1.77. What is the average Gross intake ratio(%) in Madagascar per year?
Your answer should be compact. 166.58. What is the average Gross intake ratio(%) in Moldova per year?
Offer a very short reply. 96.25. What is the average Gross intake ratio(%) in Paraguay per year?
Ensure brevity in your answer.  102.82. What is the average Gross intake ratio(%) of Tanzania per year?
Ensure brevity in your answer.  108.23. In the year 2002, what is the difference between the Gross intake ratio(%) in Madagascar and Gross intake ratio(%) in Moldova?
Your answer should be compact. 12.56. In the year 2002, what is the difference between the Gross intake ratio(%) in Madagascar and Gross intake ratio(%) in Paraguay?
Keep it short and to the point. -0.08. In the year 2002, what is the difference between the Gross intake ratio(%) in Madagascar and Gross intake ratio(%) in Tanzania?
Provide a succinct answer. -35.96. In the year 2002, what is the difference between the Gross intake ratio(%) in Moldova and Gross intake ratio(%) in Paraguay?
Keep it short and to the point. -12.65. In the year 2002, what is the difference between the Gross intake ratio(%) in Moldova and Gross intake ratio(%) in Tanzania?
Provide a short and direct response. -48.52. In the year 2002, what is the difference between the Gross intake ratio(%) in Paraguay and Gross intake ratio(%) in Tanzania?
Offer a very short reply. -35.87. In the year 2004, what is the difference between the Gross intake ratio(%) in Madagascar and Gross intake ratio(%) in Moldova?
Keep it short and to the point. 63.68. In the year 2004, what is the difference between the Gross intake ratio(%) of Madagascar and Gross intake ratio(%) of Paraguay?
Ensure brevity in your answer.  49.54. In the year 2004, what is the difference between the Gross intake ratio(%) in Madagascar and Gross intake ratio(%) in Tanzania?
Provide a short and direct response. 52.83. In the year 2004, what is the difference between the Gross intake ratio(%) of Moldova and Gross intake ratio(%) of Paraguay?
Offer a terse response. -14.14. In the year 2004, what is the difference between the Gross intake ratio(%) of Moldova and Gross intake ratio(%) of Tanzania?
Ensure brevity in your answer.  -10.85. In the year 2004, what is the difference between the Gross intake ratio(%) of Paraguay and Gross intake ratio(%) of Tanzania?
Make the answer very short. 3.29. In the year 2005, what is the difference between the Gross intake ratio(%) of Madagascar and Gross intake ratio(%) of Moldova?
Keep it short and to the point. 85.74. In the year 2005, what is the difference between the Gross intake ratio(%) of Madagascar and Gross intake ratio(%) of Paraguay?
Ensure brevity in your answer.  66.19. In the year 2005, what is the difference between the Gross intake ratio(%) of Madagascar and Gross intake ratio(%) of Tanzania?
Provide a succinct answer. 68.19. In the year 2005, what is the difference between the Gross intake ratio(%) in Moldova and Gross intake ratio(%) in Paraguay?
Offer a very short reply. -19.55. In the year 2005, what is the difference between the Gross intake ratio(%) of Moldova and Gross intake ratio(%) of Tanzania?
Your answer should be compact. -17.55. In the year 2005, what is the difference between the Gross intake ratio(%) of Paraguay and Gross intake ratio(%) of Tanzania?
Ensure brevity in your answer.  2. In the year 2006, what is the difference between the Gross intake ratio(%) in Madagascar and Gross intake ratio(%) in Moldova?
Your response must be concise. 76.16. In the year 2006, what is the difference between the Gross intake ratio(%) in Madagascar and Gross intake ratio(%) in Paraguay?
Your response must be concise. 70.02. In the year 2006, what is the difference between the Gross intake ratio(%) of Madagascar and Gross intake ratio(%) of Tanzania?
Give a very brief answer. 70.67. In the year 2006, what is the difference between the Gross intake ratio(%) in Moldova and Gross intake ratio(%) in Paraguay?
Your answer should be very brief. -6.14. In the year 2006, what is the difference between the Gross intake ratio(%) in Moldova and Gross intake ratio(%) in Tanzania?
Give a very brief answer. -5.49. In the year 2006, what is the difference between the Gross intake ratio(%) in Paraguay and Gross intake ratio(%) in Tanzania?
Make the answer very short. 0.65. In the year 2007, what is the difference between the Gross intake ratio(%) of Madagascar and Gross intake ratio(%) of Moldova?
Your answer should be compact. 69.67. In the year 2007, what is the difference between the Gross intake ratio(%) in Madagascar and Gross intake ratio(%) in Paraguay?
Ensure brevity in your answer.  66.51. In the year 2007, what is the difference between the Gross intake ratio(%) in Madagascar and Gross intake ratio(%) in Tanzania?
Give a very brief answer. 59.5. In the year 2007, what is the difference between the Gross intake ratio(%) of Moldova and Gross intake ratio(%) of Paraguay?
Offer a terse response. -3.16. In the year 2007, what is the difference between the Gross intake ratio(%) in Moldova and Gross intake ratio(%) in Tanzania?
Your answer should be very brief. -10.18. In the year 2007, what is the difference between the Gross intake ratio(%) in Paraguay and Gross intake ratio(%) in Tanzania?
Your answer should be very brief. -7.01. In the year 2009, what is the difference between the Gross intake ratio(%) in Madagascar and Gross intake ratio(%) in Moldova?
Provide a short and direct response. 90.07. In the year 2009, what is the difference between the Gross intake ratio(%) of Madagascar and Gross intake ratio(%) of Paraguay?
Your answer should be compact. 85.19. In the year 2009, what is the difference between the Gross intake ratio(%) in Madagascar and Gross intake ratio(%) in Tanzania?
Provide a succinct answer. 83.8. In the year 2009, what is the difference between the Gross intake ratio(%) in Moldova and Gross intake ratio(%) in Paraguay?
Provide a short and direct response. -4.88. In the year 2009, what is the difference between the Gross intake ratio(%) of Moldova and Gross intake ratio(%) of Tanzania?
Your answer should be very brief. -6.27. In the year 2009, what is the difference between the Gross intake ratio(%) in Paraguay and Gross intake ratio(%) in Tanzania?
Your response must be concise. -1.38. In the year 2010, what is the difference between the Gross intake ratio(%) of Madagascar and Gross intake ratio(%) of Moldova?
Give a very brief answer. 82.71. In the year 2010, what is the difference between the Gross intake ratio(%) of Madagascar and Gross intake ratio(%) of Paraguay?
Make the answer very short. 84.73. In the year 2010, what is the difference between the Gross intake ratio(%) in Madagascar and Gross intake ratio(%) in Tanzania?
Provide a short and direct response. 83.11. In the year 2010, what is the difference between the Gross intake ratio(%) of Moldova and Gross intake ratio(%) of Paraguay?
Provide a short and direct response. 2.02. In the year 2010, what is the difference between the Gross intake ratio(%) in Moldova and Gross intake ratio(%) in Tanzania?
Your answer should be compact. 0.41. In the year 2010, what is the difference between the Gross intake ratio(%) of Paraguay and Gross intake ratio(%) of Tanzania?
Provide a succinct answer. -1.61. In the year 2012, what is the difference between the Gross intake ratio(%) of Madagascar and Gross intake ratio(%) of Moldova?
Make the answer very short. 82. In the year 2012, what is the difference between the Gross intake ratio(%) of Madagascar and Gross intake ratio(%) of Paraguay?
Your response must be concise. 87.99. In the year 2012, what is the difference between the Gross intake ratio(%) of Madagascar and Gross intake ratio(%) of Tanzania?
Give a very brief answer. 84.61. In the year 2012, what is the difference between the Gross intake ratio(%) in Moldova and Gross intake ratio(%) in Paraguay?
Make the answer very short. 5.99. In the year 2012, what is the difference between the Gross intake ratio(%) in Moldova and Gross intake ratio(%) in Tanzania?
Offer a terse response. 2.61. In the year 2012, what is the difference between the Gross intake ratio(%) of Paraguay and Gross intake ratio(%) of Tanzania?
Provide a short and direct response. -3.38. What is the ratio of the Gross intake ratio(%) in Madagascar in 2002 to that in 2004?
Provide a succinct answer. 0.7. What is the ratio of the Gross intake ratio(%) of Tanzania in 2002 to that in 2004?
Keep it short and to the point. 1.35. What is the ratio of the Gross intake ratio(%) in Madagascar in 2002 to that in 2005?
Offer a terse response. 0.65. What is the ratio of the Gross intake ratio(%) of Moldova in 2002 to that in 2005?
Your response must be concise. 1.13. What is the ratio of the Gross intake ratio(%) of Paraguay in 2002 to that in 2005?
Make the answer very short. 1.04. What is the ratio of the Gross intake ratio(%) of Tanzania in 2002 to that in 2005?
Offer a very short reply. 1.4. What is the ratio of the Gross intake ratio(%) in Madagascar in 2002 to that in 2006?
Your answer should be compact. 0.66. What is the ratio of the Gross intake ratio(%) in Moldova in 2002 to that in 2006?
Provide a succinct answer. 1.05. What is the ratio of the Gross intake ratio(%) in Paraguay in 2002 to that in 2006?
Ensure brevity in your answer.  1.11. What is the ratio of the Gross intake ratio(%) of Tanzania in 2002 to that in 2006?
Keep it short and to the point. 1.46. What is the ratio of the Gross intake ratio(%) of Madagascar in 2002 to that in 2007?
Give a very brief answer. 0.69. What is the ratio of the Gross intake ratio(%) of Moldova in 2002 to that in 2007?
Offer a very short reply. 1.06. What is the ratio of the Gross intake ratio(%) in Paraguay in 2002 to that in 2007?
Your answer should be very brief. 1.16. What is the ratio of the Gross intake ratio(%) in Tanzania in 2002 to that in 2007?
Your answer should be very brief. 1.42. What is the ratio of the Gross intake ratio(%) in Madagascar in 2002 to that in 2009?
Your answer should be compact. 0.62. What is the ratio of the Gross intake ratio(%) in Moldova in 2002 to that in 2009?
Provide a succinct answer. 1.09. What is the ratio of the Gross intake ratio(%) in Paraguay in 2002 to that in 2009?
Offer a very short reply. 1.16. What is the ratio of the Gross intake ratio(%) in Tanzania in 2002 to that in 2009?
Keep it short and to the point. 1.51. What is the ratio of the Gross intake ratio(%) in Madagascar in 2002 to that in 2010?
Make the answer very short. 0.64. What is the ratio of the Gross intake ratio(%) in Moldova in 2002 to that in 2010?
Your answer should be compact. 1.05. What is the ratio of the Gross intake ratio(%) in Paraguay in 2002 to that in 2010?
Ensure brevity in your answer.  1.21. What is the ratio of the Gross intake ratio(%) of Tanzania in 2002 to that in 2010?
Provide a short and direct response. 1.56. What is the ratio of the Gross intake ratio(%) of Madagascar in 2002 to that in 2012?
Provide a short and direct response. 0.64. What is the ratio of the Gross intake ratio(%) in Moldova in 2002 to that in 2012?
Provide a short and direct response. 1.07. What is the ratio of the Gross intake ratio(%) of Paraguay in 2002 to that in 2012?
Provide a succinct answer. 1.28. What is the ratio of the Gross intake ratio(%) in Tanzania in 2002 to that in 2012?
Provide a short and direct response. 1.62. What is the ratio of the Gross intake ratio(%) of Madagascar in 2004 to that in 2005?
Provide a short and direct response. 0.93. What is the ratio of the Gross intake ratio(%) in Moldova in 2004 to that in 2005?
Your answer should be compact. 1.11. What is the ratio of the Gross intake ratio(%) in Paraguay in 2004 to that in 2005?
Provide a succinct answer. 1.04. What is the ratio of the Gross intake ratio(%) of Tanzania in 2004 to that in 2005?
Offer a very short reply. 1.03. What is the ratio of the Gross intake ratio(%) of Madagascar in 2004 to that in 2006?
Your answer should be compact. 0.94. What is the ratio of the Gross intake ratio(%) of Moldova in 2004 to that in 2006?
Ensure brevity in your answer.  1.03. What is the ratio of the Gross intake ratio(%) of Paraguay in 2004 to that in 2006?
Provide a succinct answer. 1.11. What is the ratio of the Gross intake ratio(%) of Tanzania in 2004 to that in 2006?
Your answer should be very brief. 1.08. What is the ratio of the Gross intake ratio(%) of Moldova in 2004 to that in 2007?
Offer a terse response. 1.05. What is the ratio of the Gross intake ratio(%) in Paraguay in 2004 to that in 2007?
Offer a terse response. 1.16. What is the ratio of the Gross intake ratio(%) in Tanzania in 2004 to that in 2007?
Give a very brief answer. 1.05. What is the ratio of the Gross intake ratio(%) of Madagascar in 2004 to that in 2009?
Provide a succinct answer. 0.89. What is the ratio of the Gross intake ratio(%) in Moldova in 2004 to that in 2009?
Your response must be concise. 1.07. What is the ratio of the Gross intake ratio(%) in Paraguay in 2004 to that in 2009?
Offer a very short reply. 1.16. What is the ratio of the Gross intake ratio(%) in Tanzania in 2004 to that in 2009?
Offer a very short reply. 1.11. What is the ratio of the Gross intake ratio(%) of Madagascar in 2004 to that in 2010?
Keep it short and to the point. 0.91. What is the ratio of the Gross intake ratio(%) in Moldova in 2004 to that in 2010?
Your answer should be very brief. 1.04. What is the ratio of the Gross intake ratio(%) in Paraguay in 2004 to that in 2010?
Keep it short and to the point. 1.21. What is the ratio of the Gross intake ratio(%) in Tanzania in 2004 to that in 2010?
Your response must be concise. 1.16. What is the ratio of the Gross intake ratio(%) of Madagascar in 2004 to that in 2012?
Offer a very short reply. 0.92. What is the ratio of the Gross intake ratio(%) in Moldova in 2004 to that in 2012?
Your response must be concise. 1.05. What is the ratio of the Gross intake ratio(%) of Paraguay in 2004 to that in 2012?
Your answer should be very brief. 1.28. What is the ratio of the Gross intake ratio(%) of Tanzania in 2004 to that in 2012?
Your response must be concise. 1.2. What is the ratio of the Gross intake ratio(%) of Moldova in 2005 to that in 2006?
Your response must be concise. 0.93. What is the ratio of the Gross intake ratio(%) of Paraguay in 2005 to that in 2006?
Offer a terse response. 1.06. What is the ratio of the Gross intake ratio(%) in Tanzania in 2005 to that in 2006?
Make the answer very short. 1.05. What is the ratio of the Gross intake ratio(%) of Madagascar in 2005 to that in 2007?
Keep it short and to the point. 1.06. What is the ratio of the Gross intake ratio(%) in Moldova in 2005 to that in 2007?
Your response must be concise. 0.94. What is the ratio of the Gross intake ratio(%) in Paraguay in 2005 to that in 2007?
Offer a terse response. 1.11. What is the ratio of the Gross intake ratio(%) in Tanzania in 2005 to that in 2007?
Make the answer very short. 1.02. What is the ratio of the Gross intake ratio(%) in Madagascar in 2005 to that in 2009?
Keep it short and to the point. 0.96. What is the ratio of the Gross intake ratio(%) in Moldova in 2005 to that in 2009?
Provide a succinct answer. 0.97. What is the ratio of the Gross intake ratio(%) of Paraguay in 2005 to that in 2009?
Give a very brief answer. 1.12. What is the ratio of the Gross intake ratio(%) in Tanzania in 2005 to that in 2009?
Your response must be concise. 1.08. What is the ratio of the Gross intake ratio(%) in Madagascar in 2005 to that in 2010?
Provide a succinct answer. 0.98. What is the ratio of the Gross intake ratio(%) in Moldova in 2005 to that in 2010?
Your answer should be compact. 0.93. What is the ratio of the Gross intake ratio(%) of Paraguay in 2005 to that in 2010?
Offer a very short reply. 1.16. What is the ratio of the Gross intake ratio(%) of Tanzania in 2005 to that in 2010?
Provide a succinct answer. 1.12. What is the ratio of the Gross intake ratio(%) of Madagascar in 2005 to that in 2012?
Provide a short and direct response. 0.99. What is the ratio of the Gross intake ratio(%) of Moldova in 2005 to that in 2012?
Provide a short and direct response. 0.95. What is the ratio of the Gross intake ratio(%) in Paraguay in 2005 to that in 2012?
Your answer should be compact. 1.23. What is the ratio of the Gross intake ratio(%) of Tanzania in 2005 to that in 2012?
Give a very brief answer. 1.16. What is the ratio of the Gross intake ratio(%) of Madagascar in 2006 to that in 2007?
Provide a short and direct response. 1.05. What is the ratio of the Gross intake ratio(%) of Moldova in 2006 to that in 2007?
Make the answer very short. 1.02. What is the ratio of the Gross intake ratio(%) of Paraguay in 2006 to that in 2007?
Keep it short and to the point. 1.05. What is the ratio of the Gross intake ratio(%) in Madagascar in 2006 to that in 2009?
Keep it short and to the point. 0.95. What is the ratio of the Gross intake ratio(%) in Moldova in 2006 to that in 2009?
Make the answer very short. 1.04. What is the ratio of the Gross intake ratio(%) in Paraguay in 2006 to that in 2009?
Your answer should be very brief. 1.05. What is the ratio of the Gross intake ratio(%) in Tanzania in 2006 to that in 2009?
Your answer should be compact. 1.03. What is the ratio of the Gross intake ratio(%) in Madagascar in 2006 to that in 2010?
Make the answer very short. 0.97. What is the ratio of the Gross intake ratio(%) of Moldova in 2006 to that in 2010?
Your answer should be compact. 1.01. What is the ratio of the Gross intake ratio(%) in Paraguay in 2006 to that in 2010?
Give a very brief answer. 1.09. What is the ratio of the Gross intake ratio(%) in Tanzania in 2006 to that in 2010?
Make the answer very short. 1.07. What is the ratio of the Gross intake ratio(%) of Madagascar in 2006 to that in 2012?
Make the answer very short. 0.98. What is the ratio of the Gross intake ratio(%) in Moldova in 2006 to that in 2012?
Give a very brief answer. 1.02. What is the ratio of the Gross intake ratio(%) in Paraguay in 2006 to that in 2012?
Offer a terse response. 1.16. What is the ratio of the Gross intake ratio(%) in Tanzania in 2006 to that in 2012?
Give a very brief answer. 1.11. What is the ratio of the Gross intake ratio(%) in Madagascar in 2007 to that in 2009?
Ensure brevity in your answer.  0.9. What is the ratio of the Gross intake ratio(%) of Moldova in 2007 to that in 2009?
Provide a short and direct response. 1.03. What is the ratio of the Gross intake ratio(%) in Paraguay in 2007 to that in 2009?
Provide a short and direct response. 1.01. What is the ratio of the Gross intake ratio(%) of Tanzania in 2007 to that in 2009?
Ensure brevity in your answer.  1.06. What is the ratio of the Gross intake ratio(%) of Madagascar in 2007 to that in 2010?
Provide a succinct answer. 0.92. What is the ratio of the Gross intake ratio(%) of Moldova in 2007 to that in 2010?
Your response must be concise. 0.99. What is the ratio of the Gross intake ratio(%) in Paraguay in 2007 to that in 2010?
Make the answer very short. 1.05. What is the ratio of the Gross intake ratio(%) in Tanzania in 2007 to that in 2010?
Ensure brevity in your answer.  1.1. What is the ratio of the Gross intake ratio(%) in Madagascar in 2007 to that in 2012?
Provide a succinct answer. 0.93. What is the ratio of the Gross intake ratio(%) in Moldova in 2007 to that in 2012?
Keep it short and to the point. 1. What is the ratio of the Gross intake ratio(%) of Paraguay in 2007 to that in 2012?
Provide a succinct answer. 1.11. What is the ratio of the Gross intake ratio(%) of Tanzania in 2007 to that in 2012?
Provide a succinct answer. 1.14. What is the ratio of the Gross intake ratio(%) in Madagascar in 2009 to that in 2010?
Your response must be concise. 1.02. What is the ratio of the Gross intake ratio(%) in Moldova in 2009 to that in 2010?
Your response must be concise. 0.97. What is the ratio of the Gross intake ratio(%) of Paraguay in 2009 to that in 2010?
Your response must be concise. 1.04. What is the ratio of the Gross intake ratio(%) in Tanzania in 2009 to that in 2010?
Provide a short and direct response. 1.04. What is the ratio of the Gross intake ratio(%) of Madagascar in 2009 to that in 2012?
Your answer should be very brief. 1.03. What is the ratio of the Gross intake ratio(%) in Moldova in 2009 to that in 2012?
Your answer should be very brief. 0.98. What is the ratio of the Gross intake ratio(%) of Paraguay in 2009 to that in 2012?
Your answer should be compact. 1.1. What is the ratio of the Gross intake ratio(%) in Tanzania in 2009 to that in 2012?
Offer a terse response. 1.07. What is the ratio of the Gross intake ratio(%) in Madagascar in 2010 to that in 2012?
Ensure brevity in your answer.  1.01. What is the ratio of the Gross intake ratio(%) in Moldova in 2010 to that in 2012?
Offer a very short reply. 1.01. What is the ratio of the Gross intake ratio(%) of Paraguay in 2010 to that in 2012?
Keep it short and to the point. 1.06. What is the ratio of the Gross intake ratio(%) in Tanzania in 2010 to that in 2012?
Provide a short and direct response. 1.04. What is the difference between the highest and the second highest Gross intake ratio(%) of Madagascar?
Your response must be concise. 4.14. What is the difference between the highest and the second highest Gross intake ratio(%) in Moldova?
Offer a very short reply. 1.5. What is the difference between the highest and the second highest Gross intake ratio(%) in Paraguay?
Make the answer very short. 0.02. What is the difference between the highest and the second highest Gross intake ratio(%) of Tanzania?
Offer a very short reply. 39.18. What is the difference between the highest and the lowest Gross intake ratio(%) in Madagascar?
Your response must be concise. 69.13. What is the difference between the highest and the lowest Gross intake ratio(%) in Moldova?
Your answer should be compact. 11.58. What is the difference between the highest and the lowest Gross intake ratio(%) of Paraguay?
Your response must be concise. 24.98. What is the difference between the highest and the lowest Gross intake ratio(%) in Tanzania?
Provide a succinct answer. 57.47. 